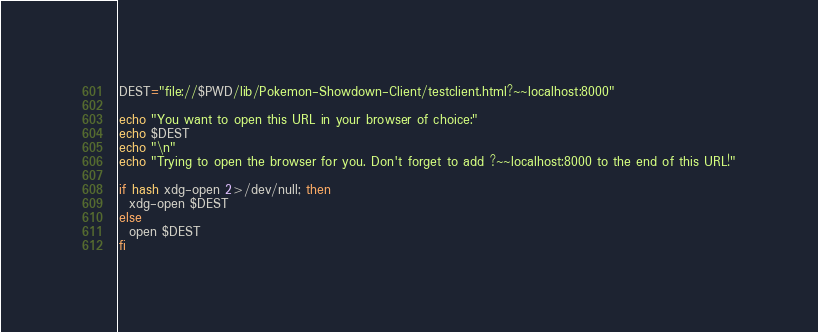<code> <loc_0><loc_0><loc_500><loc_500><_Bash_>DEST="file://$PWD/lib/Pokemon-Showdown-Client/testclient.html?~~localhost:8000"

echo "You want to open this URL in your browser of choice:"
echo $DEST
echo "\n"
echo "Trying to open the browser for you. Don't forget to add ?~~localhost:8000 to the end of this URL!"

if hash xdg-open 2>/dev/null; then
  xdg-open $DEST
else
  open $DEST
fi
</code> 